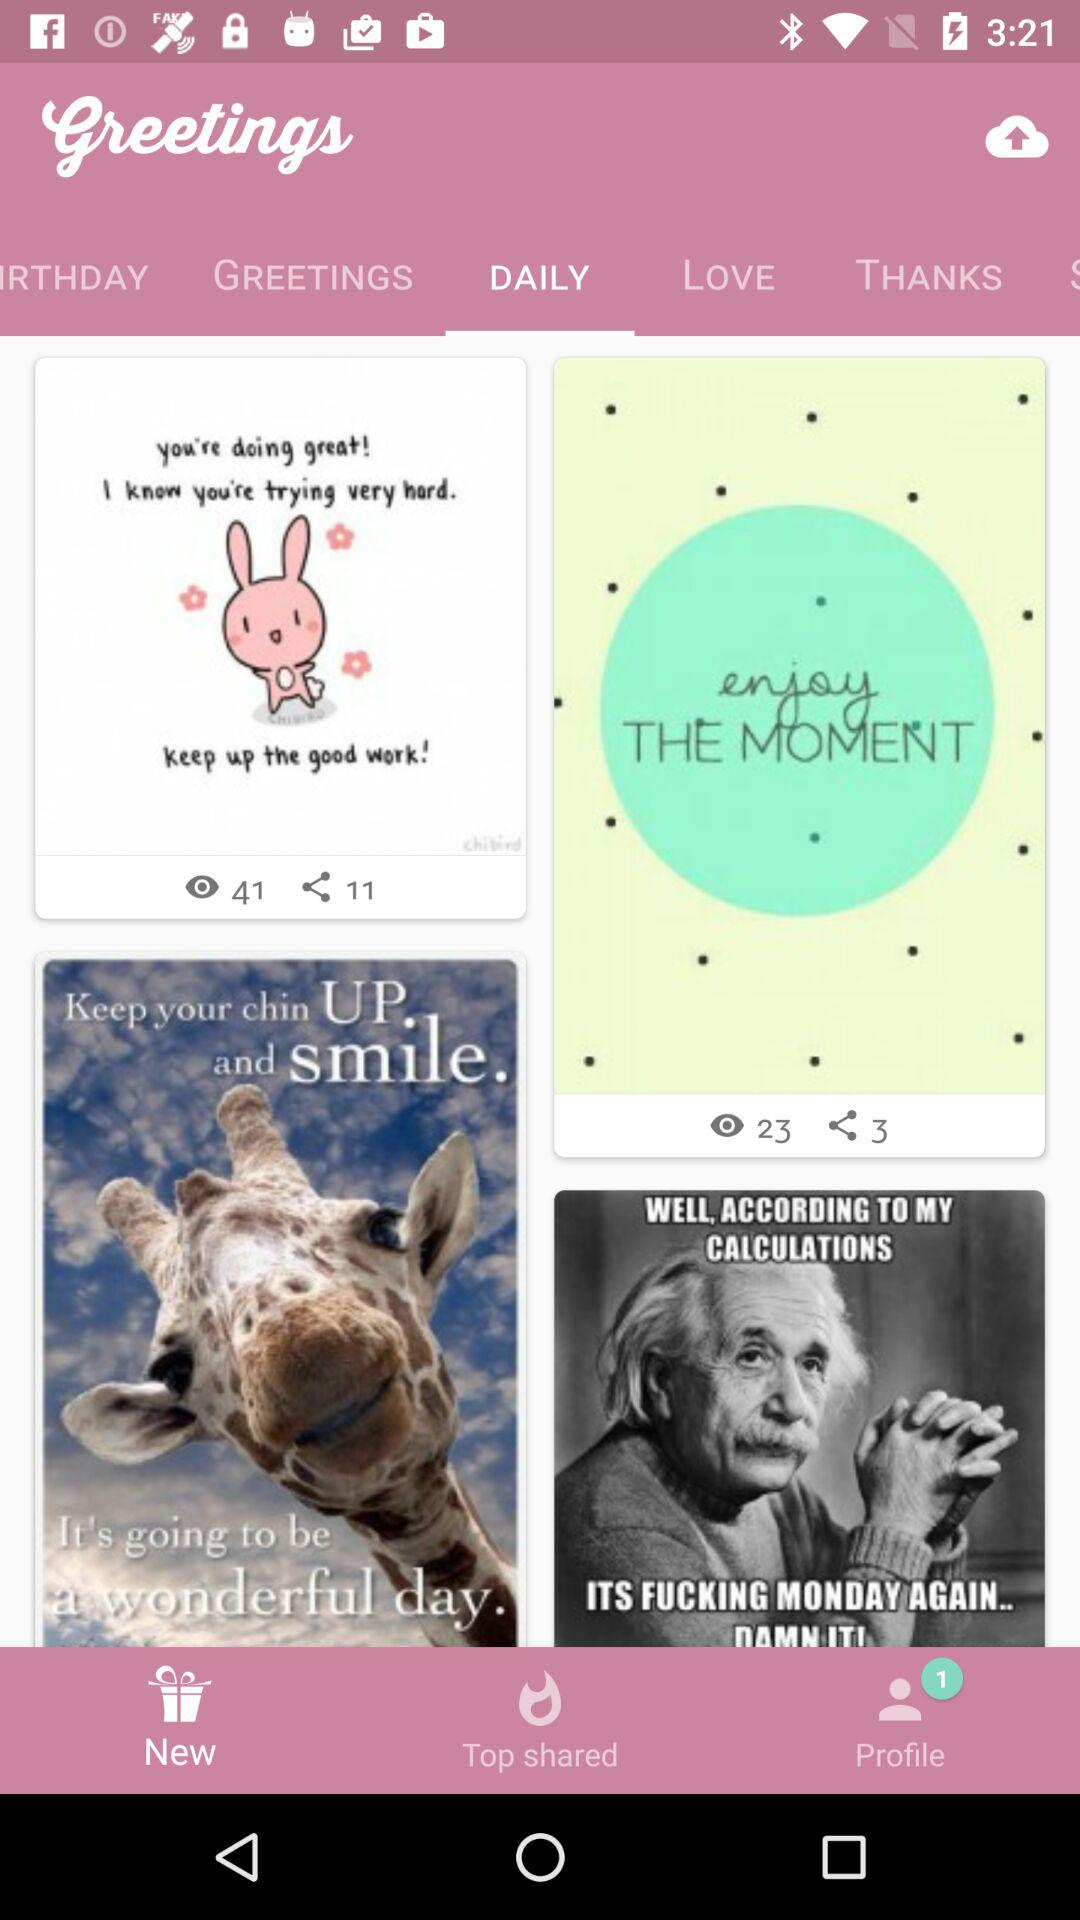How many people have shared the "enjoy THE MOMENT" greeting? There are 3 people who have shared the "enjoy THE MOMENT" greeting. 